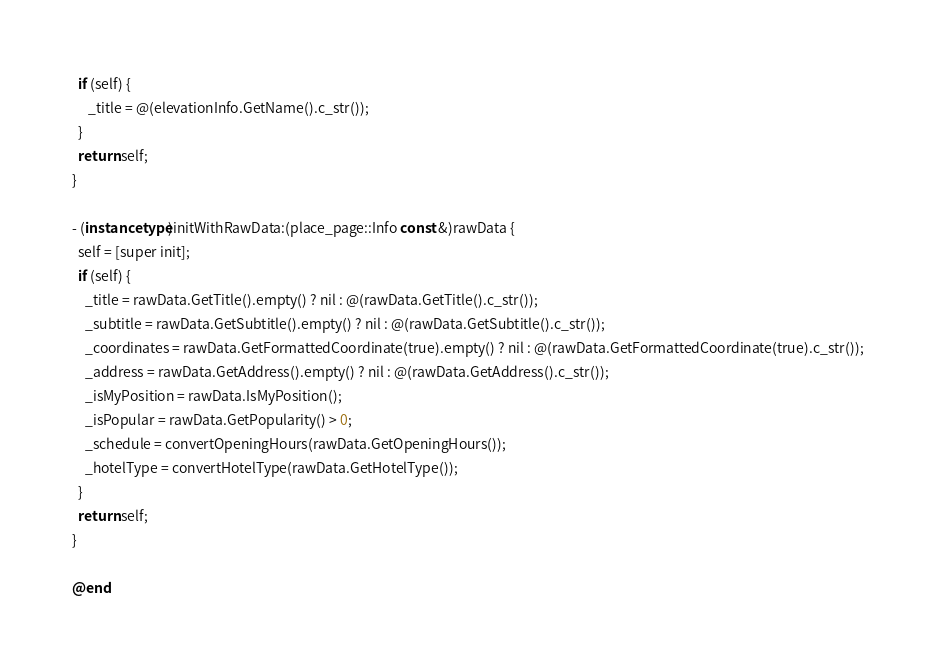Convert code to text. <code><loc_0><loc_0><loc_500><loc_500><_ObjectiveC_>  if (self) {
     _title = @(elevationInfo.GetName().c_str());
  }
  return self;
}

- (instancetype)initWithRawData:(place_page::Info const &)rawData {
  self = [super init];
  if (self) {
    _title = rawData.GetTitle().empty() ? nil : @(rawData.GetTitle().c_str());
    _subtitle = rawData.GetSubtitle().empty() ? nil : @(rawData.GetSubtitle().c_str());
    _coordinates = rawData.GetFormattedCoordinate(true).empty() ? nil : @(rawData.GetFormattedCoordinate(true).c_str());
    _address = rawData.GetAddress().empty() ? nil : @(rawData.GetAddress().c_str());
    _isMyPosition = rawData.IsMyPosition();
    _isPopular = rawData.GetPopularity() > 0;
    _schedule = convertOpeningHours(rawData.GetOpeningHours());
    _hotelType = convertHotelType(rawData.GetHotelType());
  }
  return self;
}

@end
</code> 